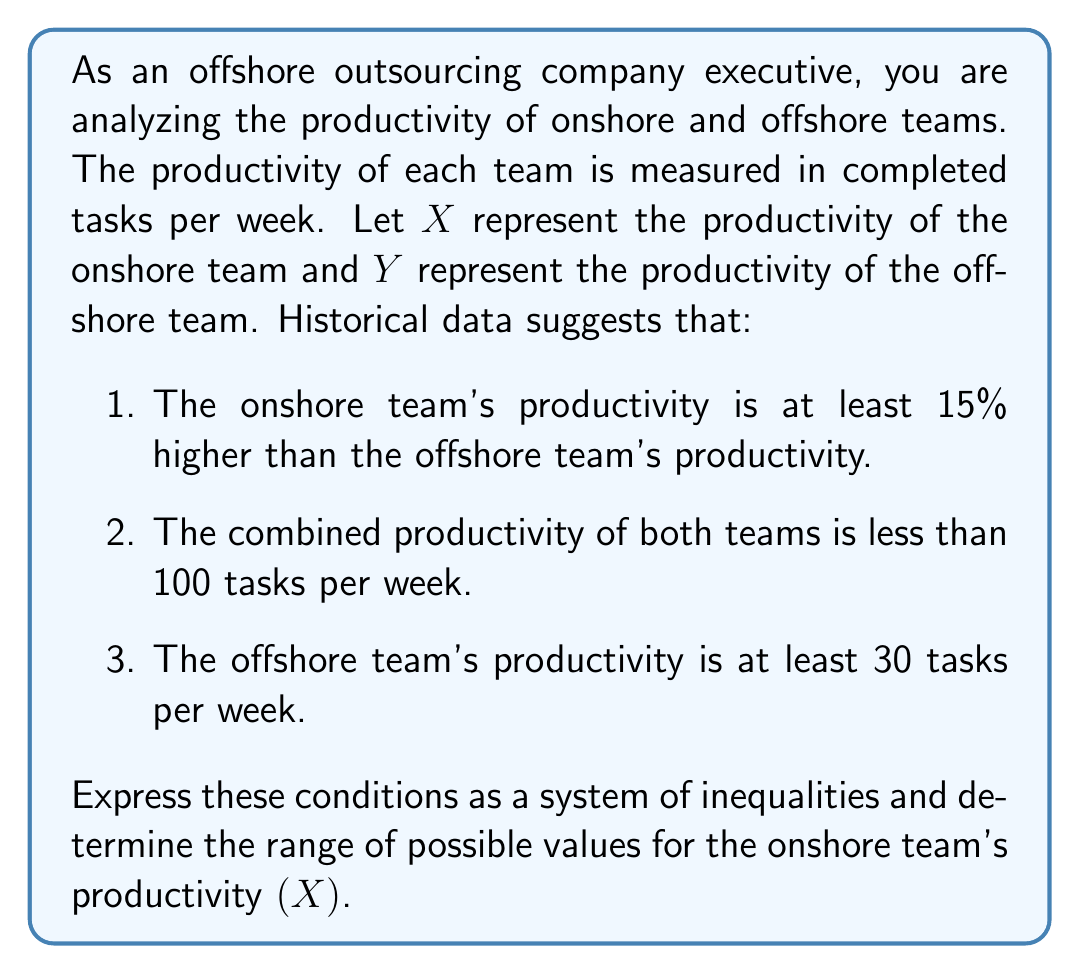Can you solve this math problem? Let's approach this step-by-step:

1. Expressing the conditions as inequalities:

   a. Onshore team's productivity is at least 15% higher than offshore team's:
      $X \geq 1.15Y$

   b. Combined productivity is less than 100 tasks per week:
      $X + Y < 100$

   c. Offshore team's productivity is at least 30 tasks per week:
      $Y \geq 30$

2. To find the range of $X$, we need to solve this system of inequalities:

   $$\begin{cases}
   X \geq 1.15Y \\
   X + Y < 100 \\
   Y \geq 30
   \end{cases}$$

3. From the third inequality, we know $Y \geq 30$. Substituting this into the first inequality:
   $X \geq 1.15(30) = 34.5$

4. To find the upper bound of $X$, we use the second inequality:
   $X + Y < 100$
   $X < 100 - Y$

   Since $Y \geq 30$, the maximum value of $X$ occurs when $Y$ is at its minimum:
   $X < 100 - 30 = 70$

5. Therefore, the range of $X$ is:
   $34.5 \leq X < 70$
Answer: The range of possible values for the onshore team's productivity $(X)$ is $34.5 \leq X < 70$ tasks per week. 